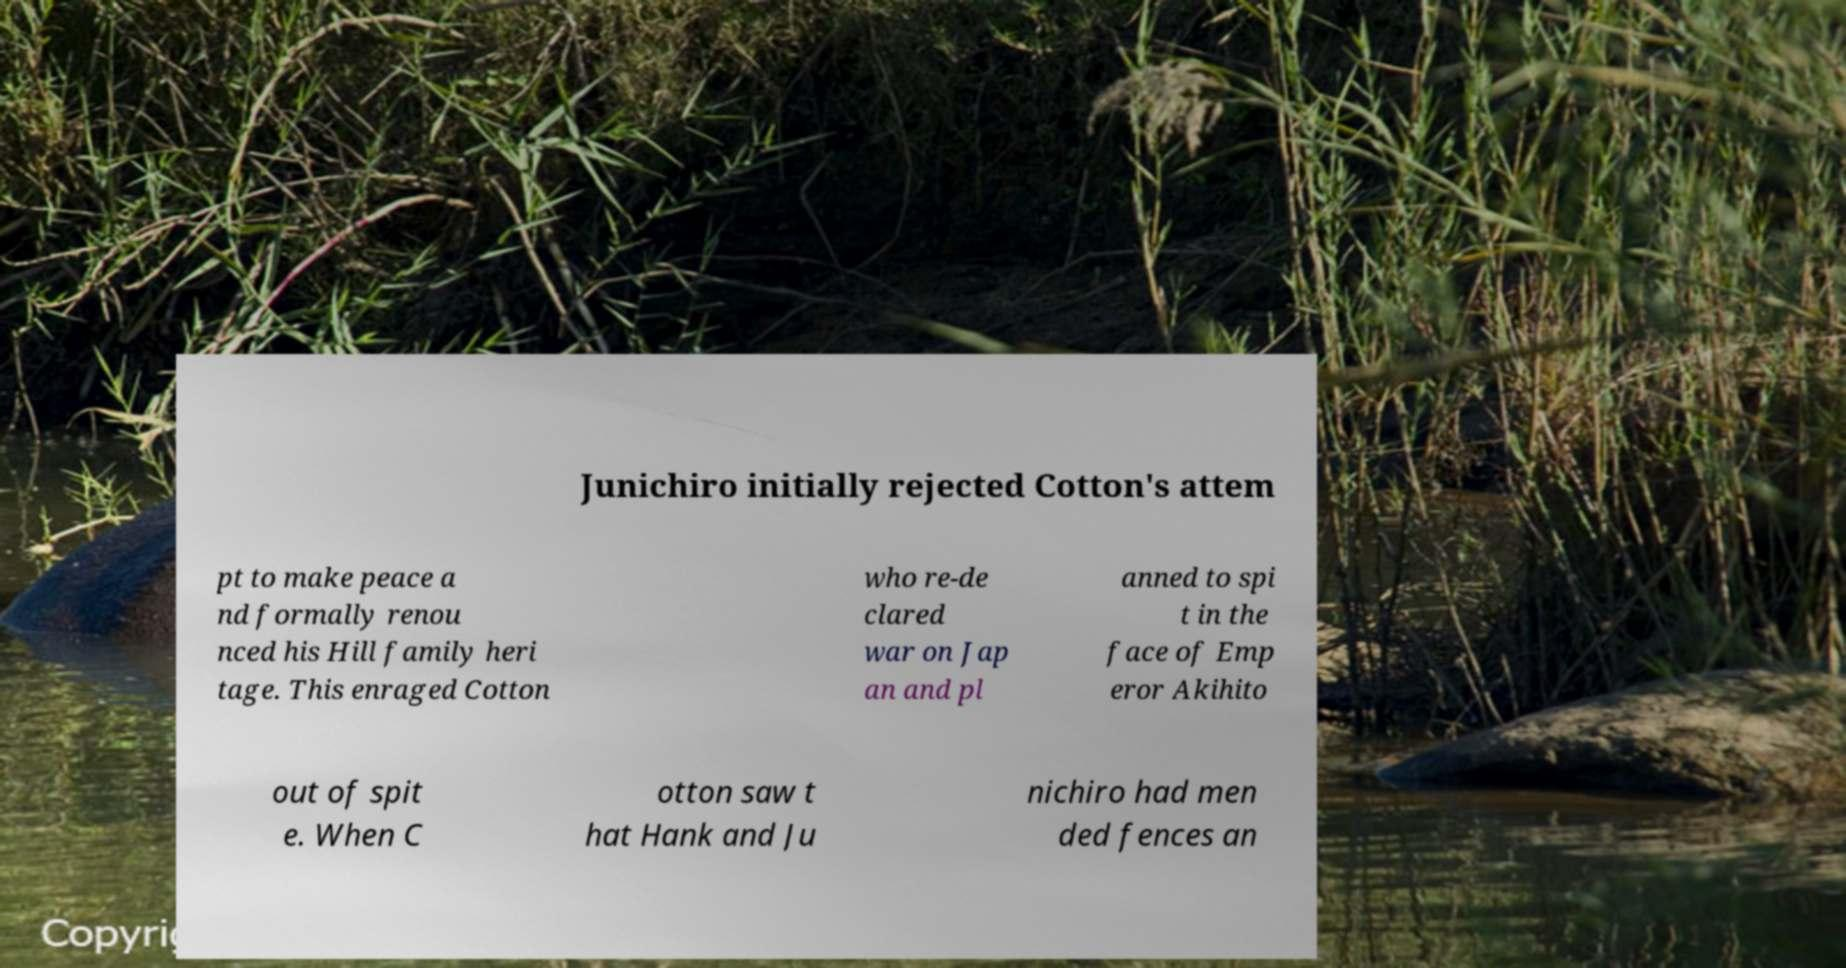Could you extract and type out the text from this image? Junichiro initially rejected Cotton's attem pt to make peace a nd formally renou nced his Hill family heri tage. This enraged Cotton who re-de clared war on Jap an and pl anned to spi t in the face of Emp eror Akihito out of spit e. When C otton saw t hat Hank and Ju nichiro had men ded fences an 